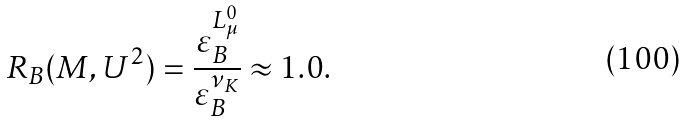Convert formula to latex. <formula><loc_0><loc_0><loc_500><loc_500>R _ { B } ( M , U ^ { 2 } ) = \frac { \varepsilon _ { B } ^ { L _ { \mu } ^ { 0 } } } { \varepsilon _ { B } ^ { \nu _ { K } } } \approx 1 . 0 .</formula> 